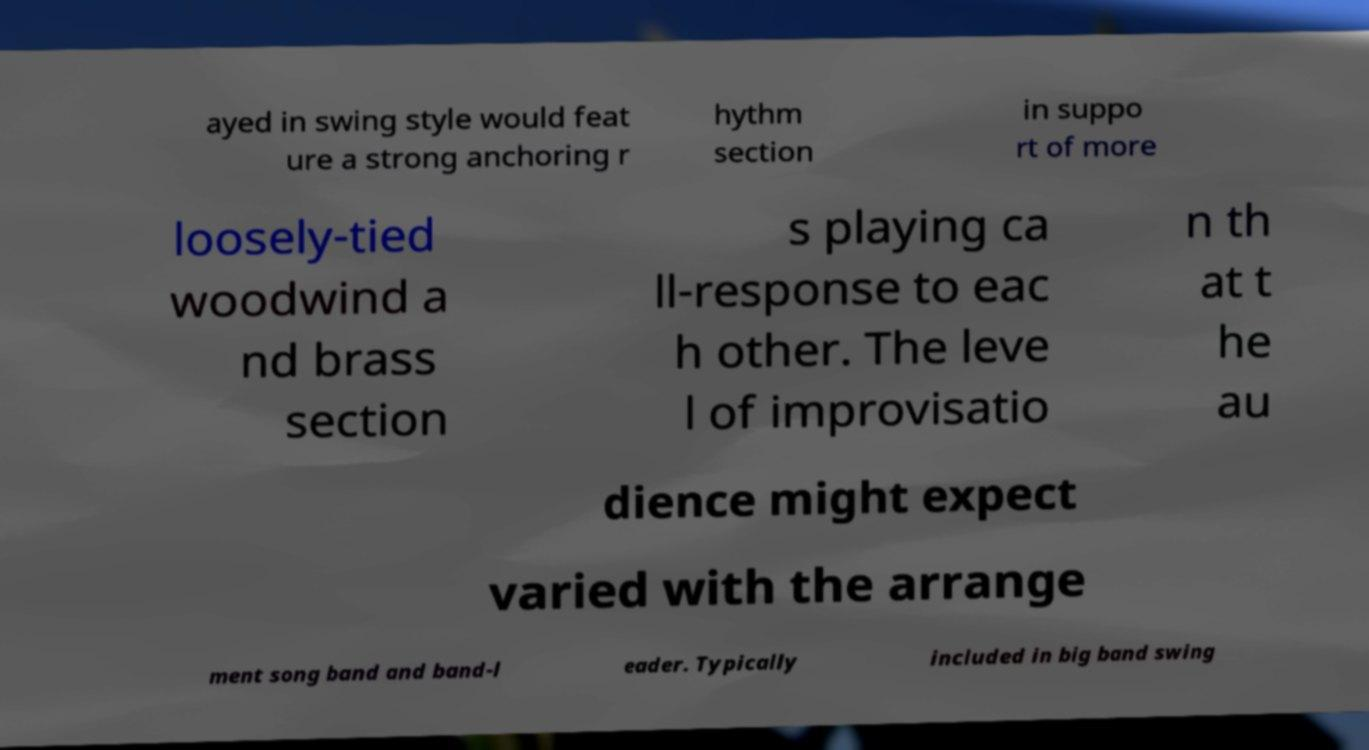I need the written content from this picture converted into text. Can you do that? ayed in swing style would feat ure a strong anchoring r hythm section in suppo rt of more loosely-tied woodwind a nd brass section s playing ca ll-response to eac h other. The leve l of improvisatio n th at t he au dience might expect varied with the arrange ment song band and band-l eader. Typically included in big band swing 